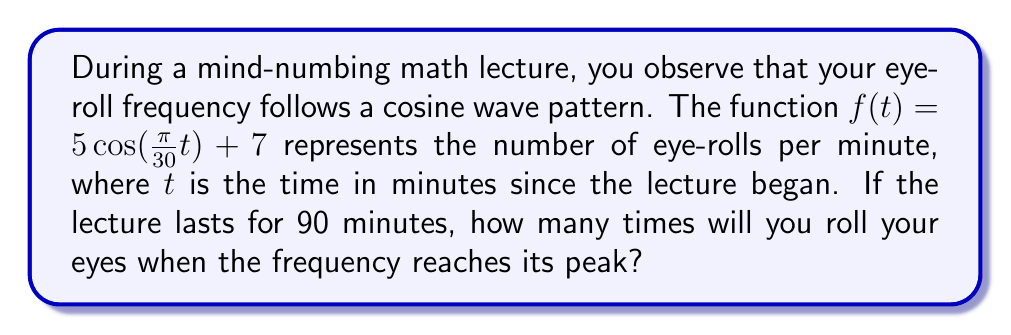Can you solve this math problem? Let's break this down step-by-step:

1) The cosine function $f(t) = 5\cos(\frac{\pi}{30}t) + 7$ represents the eye-roll frequency.

2) To find the maximum value of this function, we need to consider when $\cos(\frac{\pi}{30}t)$ equals 1, its maximum value.

3) The amplitude of the cosine wave is 5, and it's shifted up by 7 units.

4) Therefore, the maximum value of $f(t)$ is:

   $$5 \cdot 1 + 7 = 12$$

5) This means at the peak of the frequency, you'll roll your eyes 12 times per minute.

6) The question doesn't ask how many times you'll reach this peak during the 90-minute lecture. It only asks for the number of eye-rolls at the peak frequency.
Answer: 12 eye-rolls per minute 